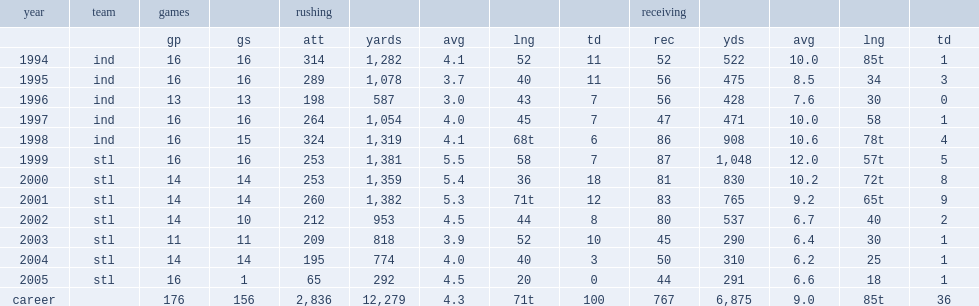How many rushing yards did faulk get in 1994? 1282.0. 